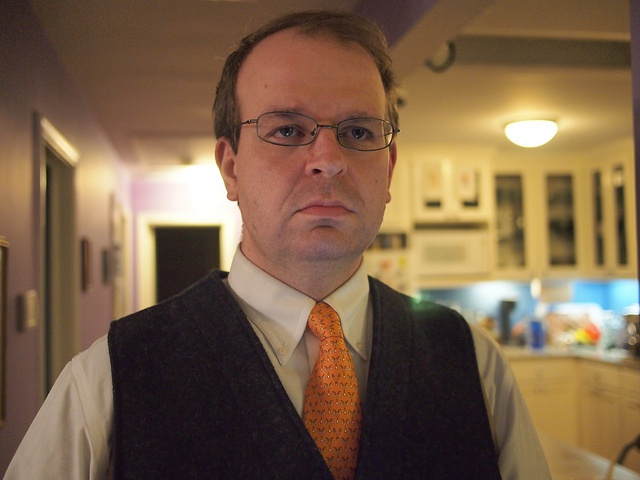Describe the objects in this image and their specific colors. I can see people in black, brown, and maroon tones, tie in black, brown, maroon, and red tones, and refrigerator in black and tan tones in this image. 